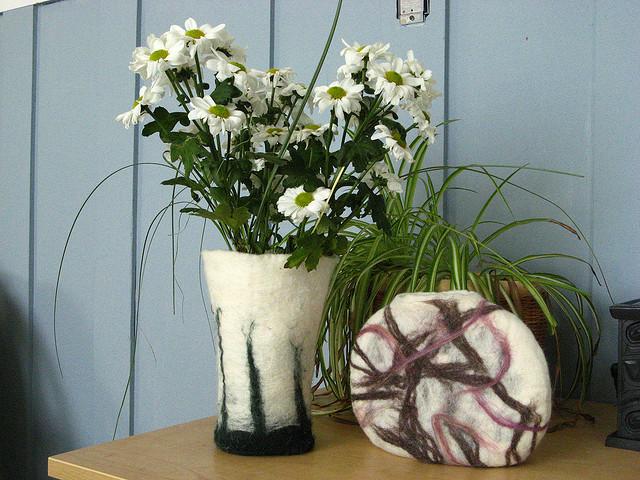Is the wall blue?
Write a very short answer. Yes. Do the flowers come from a nursery?
Keep it brief. No. Are the flowers purple?
Concise answer only. No. What is the pattern on the vase?
Be succinct. Abstract. What kind of flower is in the tall vase?
Be succinct. Daisy. 